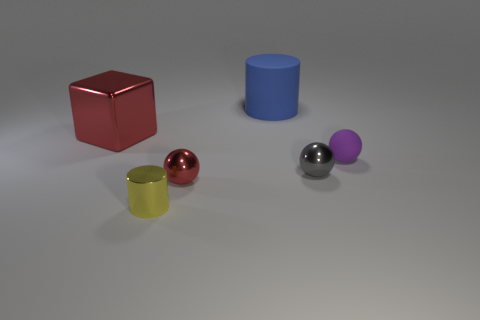What number of other objects are there of the same color as the big cube?
Make the answer very short. 1. Are there any cyan shiny things of the same shape as the big blue matte thing?
Provide a short and direct response. No. There is a gray thing; does it have the same shape as the matte thing to the right of the blue matte thing?
Offer a terse response. Yes. What size is the thing that is both behind the purple matte object and on the right side of the red block?
Provide a short and direct response. Large. How many cubes are there?
Provide a succinct answer. 1. What material is the purple sphere that is the same size as the yellow metallic cylinder?
Make the answer very short. Rubber. Is there a shiny block that has the same size as the red metallic ball?
Your response must be concise. No. Does the metal object that is behind the small purple sphere have the same color as the ball that is in front of the tiny gray sphere?
Keep it short and to the point. Yes. How many rubber objects are either tiny yellow objects or tiny red spheres?
Your answer should be compact. 0. There is a sphere behind the tiny metallic thing that is behind the small red shiny thing; what number of large red metallic blocks are behind it?
Offer a terse response. 1. 